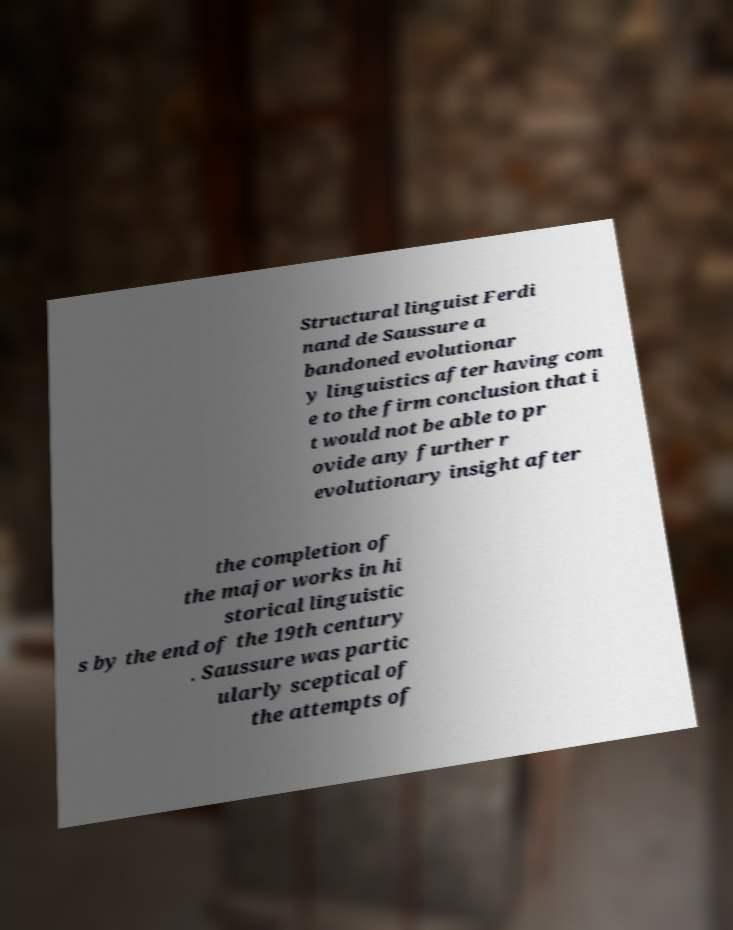Please identify and transcribe the text found in this image. Structural linguist Ferdi nand de Saussure a bandoned evolutionar y linguistics after having com e to the firm conclusion that i t would not be able to pr ovide any further r evolutionary insight after the completion of the major works in hi storical linguistic s by the end of the 19th century . Saussure was partic ularly sceptical of the attempts of 